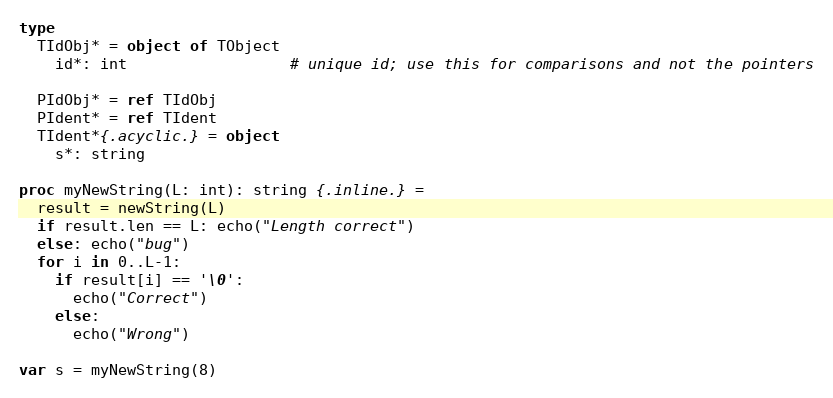Convert code to text. <code><loc_0><loc_0><loc_500><loc_500><_Nim_>
type
  TIdObj* = object of TObject
    id*: int                  # unique id; use this for comparisons and not the pointers
  
  PIdObj* = ref TIdObj
  PIdent* = ref TIdent
  TIdent*{.acyclic.} = object
    s*: string

proc myNewString(L: int): string {.inline.} =
  result = newString(L)
  if result.len == L: echo("Length correct")
  else: echo("bug")
  for i in 0..L-1:
    if result[i] == '\0':
      echo("Correct")
    else: 
      echo("Wrong")
  
var s = myNewString(8)

</code> 